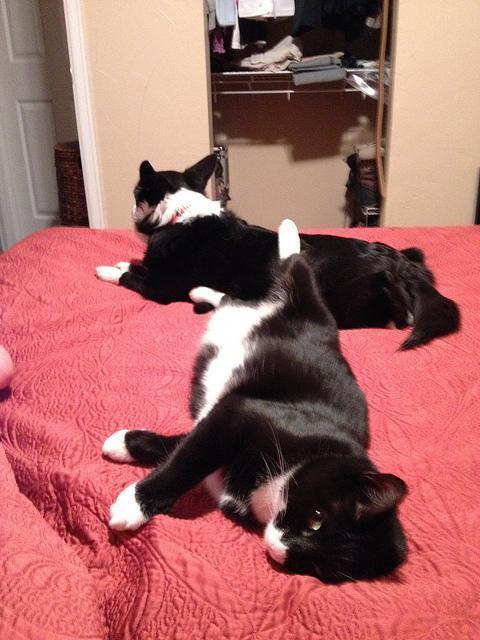How many cats are there?
Give a very brief answer. 2. 